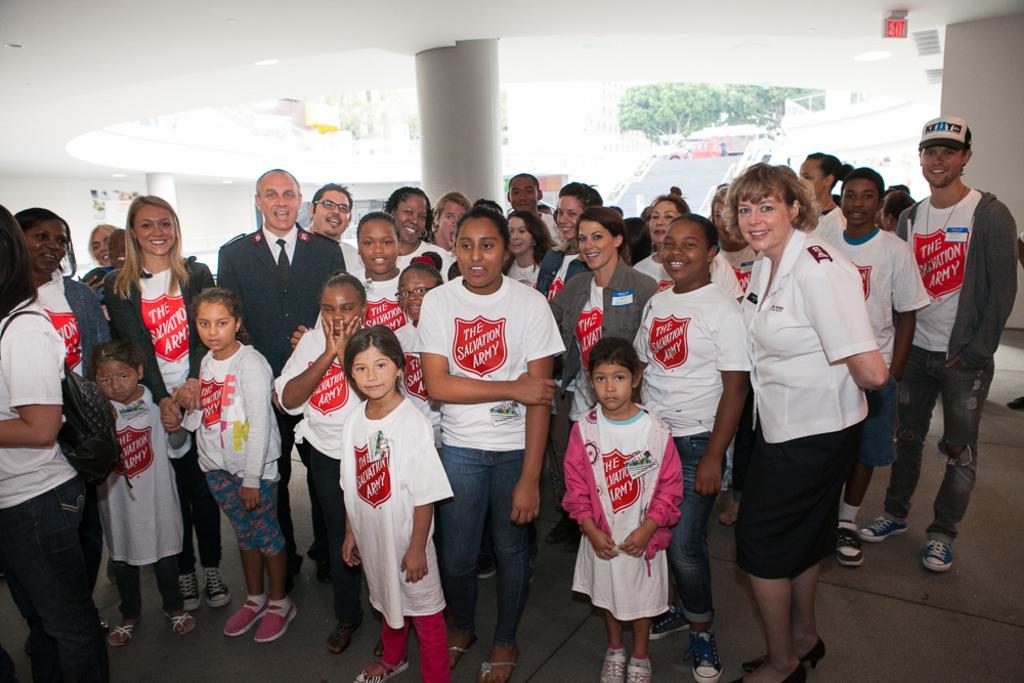Can you describe this image briefly? In this picture, we see the children, men and the women are standing. Behind them, we see a white pillar. On the right side, we see a white wall. In the background, we see the trees, buildings and a wall on which the posters are pasted. 